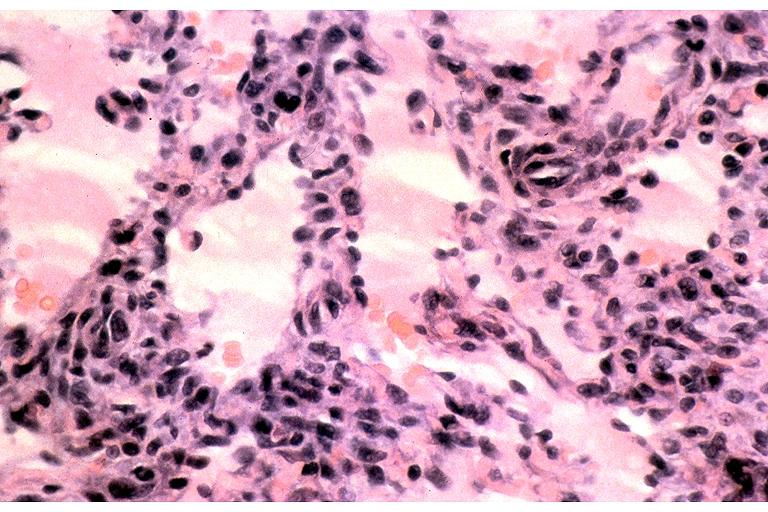s bone, clivus present?
Answer the question using a single word or phrase. No 